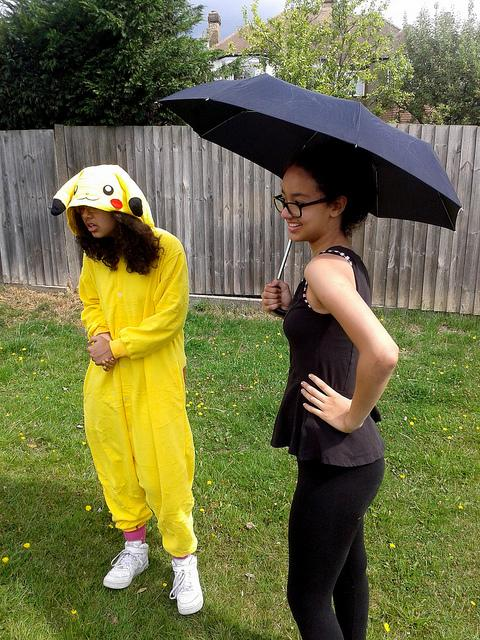What do the girls use the umbrella to avoid in this situation? sun 